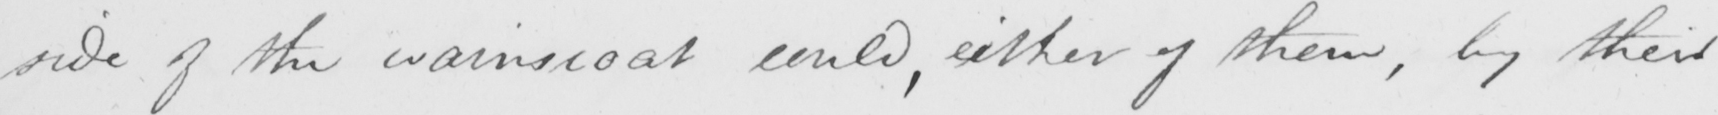Can you tell me what this handwritten text says? side of the wainscoat could , either of them , by their 